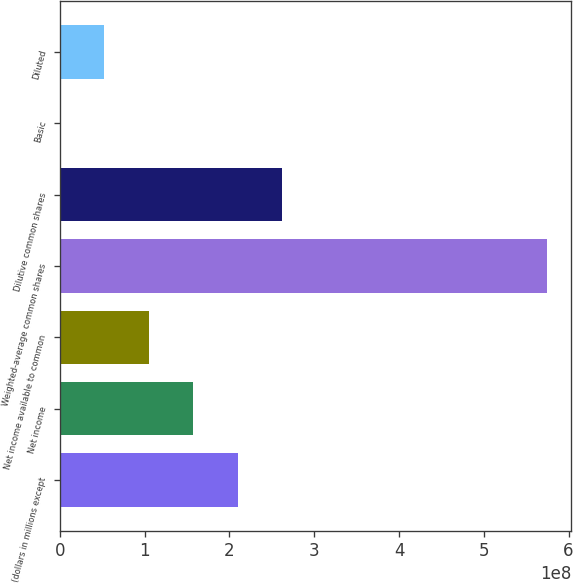Convert chart to OTSL. <chart><loc_0><loc_0><loc_500><loc_500><bar_chart><fcel>(dollars in millions except<fcel>Net income<fcel>Net income available to common<fcel>Weighted-average common shares<fcel>Dilutive common shares<fcel>Basic<fcel>Diluted<nl><fcel>2.09572e+08<fcel>1.57179e+08<fcel>1.04786e+08<fcel>5.74487e+08<fcel>2.61965e+08<fcel>1.97<fcel>5.23931e+07<nl></chart> 